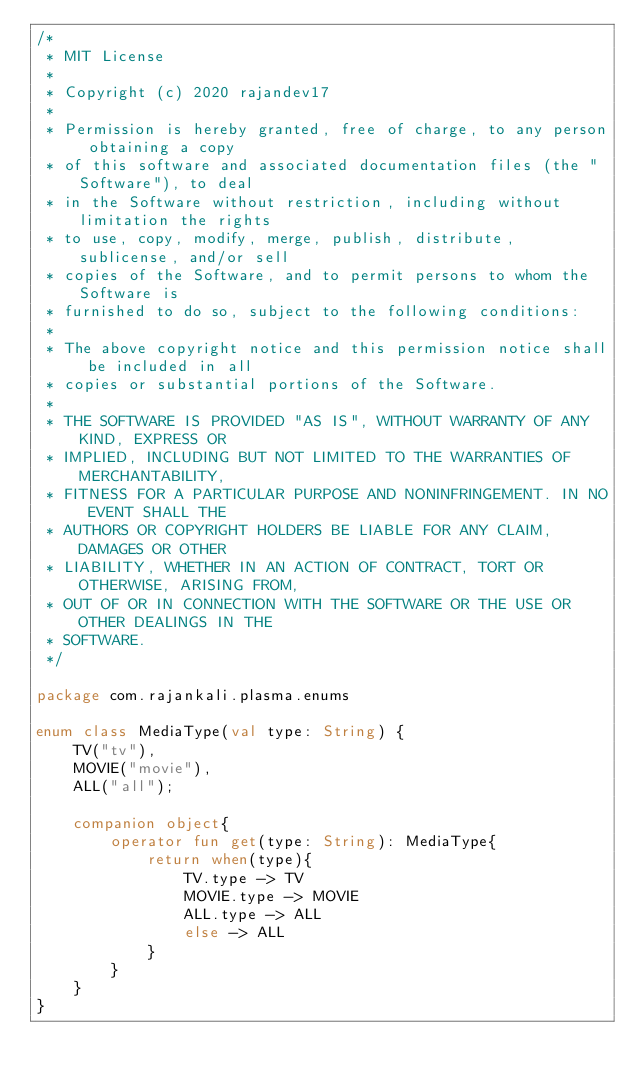Convert code to text. <code><loc_0><loc_0><loc_500><loc_500><_Kotlin_>/*
 * MIT License
 *
 * Copyright (c) 2020 rajandev17
 *
 * Permission is hereby granted, free of charge, to any person obtaining a copy
 * of this software and associated documentation files (the "Software"), to deal
 * in the Software without restriction, including without limitation the rights
 * to use, copy, modify, merge, publish, distribute, sublicense, and/or sell
 * copies of the Software, and to permit persons to whom the Software is
 * furnished to do so, subject to the following conditions:
 *
 * The above copyright notice and this permission notice shall be included in all
 * copies or substantial portions of the Software.
 *
 * THE SOFTWARE IS PROVIDED "AS IS", WITHOUT WARRANTY OF ANY KIND, EXPRESS OR
 * IMPLIED, INCLUDING BUT NOT LIMITED TO THE WARRANTIES OF MERCHANTABILITY,
 * FITNESS FOR A PARTICULAR PURPOSE AND NONINFRINGEMENT. IN NO EVENT SHALL THE
 * AUTHORS OR COPYRIGHT HOLDERS BE LIABLE FOR ANY CLAIM, DAMAGES OR OTHER
 * LIABILITY, WHETHER IN AN ACTION OF CONTRACT, TORT OR OTHERWISE, ARISING FROM,
 * OUT OF OR IN CONNECTION WITH THE SOFTWARE OR THE USE OR OTHER DEALINGS IN THE
 * SOFTWARE.
 */

package com.rajankali.plasma.enums

enum class MediaType(val type: String) {
    TV("tv"),
    MOVIE("movie"),
    ALL("all");

    companion object{
        operator fun get(type: String): MediaType{
            return when(type){
                TV.type -> TV
                MOVIE.type -> MOVIE
                ALL.type -> ALL
                else -> ALL
            }
        }
    }
}</code> 